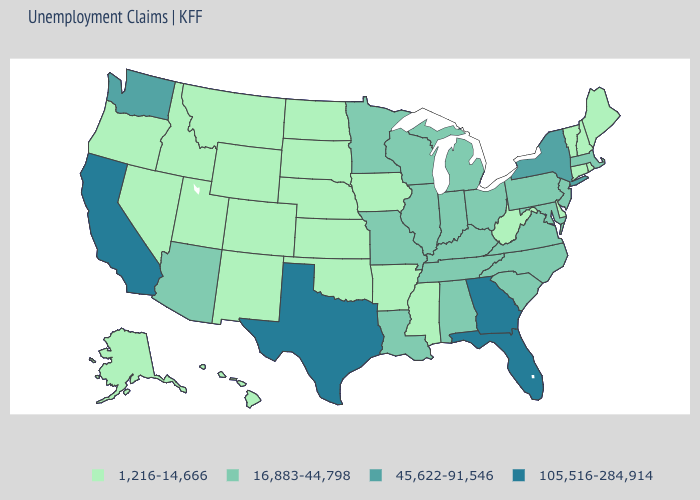Does the map have missing data?
Give a very brief answer. No. What is the highest value in states that border Wyoming?
Answer briefly. 1,216-14,666. What is the value of West Virginia?
Be succinct. 1,216-14,666. Name the states that have a value in the range 105,516-284,914?
Quick response, please. California, Florida, Georgia, Texas. What is the value of Wyoming?
Keep it brief. 1,216-14,666. Does California have the highest value in the USA?
Write a very short answer. Yes. Name the states that have a value in the range 1,216-14,666?
Short answer required. Alaska, Arkansas, Colorado, Connecticut, Delaware, Hawaii, Idaho, Iowa, Kansas, Maine, Mississippi, Montana, Nebraska, Nevada, New Hampshire, New Mexico, North Dakota, Oklahoma, Oregon, Rhode Island, South Dakota, Utah, Vermont, West Virginia, Wyoming. Name the states that have a value in the range 45,622-91,546?
Short answer required. New York, Washington. Among the states that border Kansas , does Oklahoma have the highest value?
Be succinct. No. What is the lowest value in states that border Kentucky?
Keep it brief. 1,216-14,666. Name the states that have a value in the range 16,883-44,798?
Short answer required. Alabama, Arizona, Illinois, Indiana, Kentucky, Louisiana, Maryland, Massachusetts, Michigan, Minnesota, Missouri, New Jersey, North Carolina, Ohio, Pennsylvania, South Carolina, Tennessee, Virginia, Wisconsin. Name the states that have a value in the range 105,516-284,914?
Keep it brief. California, Florida, Georgia, Texas. Does California have a higher value than Texas?
Short answer required. No. Which states have the lowest value in the USA?
Concise answer only. Alaska, Arkansas, Colorado, Connecticut, Delaware, Hawaii, Idaho, Iowa, Kansas, Maine, Mississippi, Montana, Nebraska, Nevada, New Hampshire, New Mexico, North Dakota, Oklahoma, Oregon, Rhode Island, South Dakota, Utah, Vermont, West Virginia, Wyoming. 